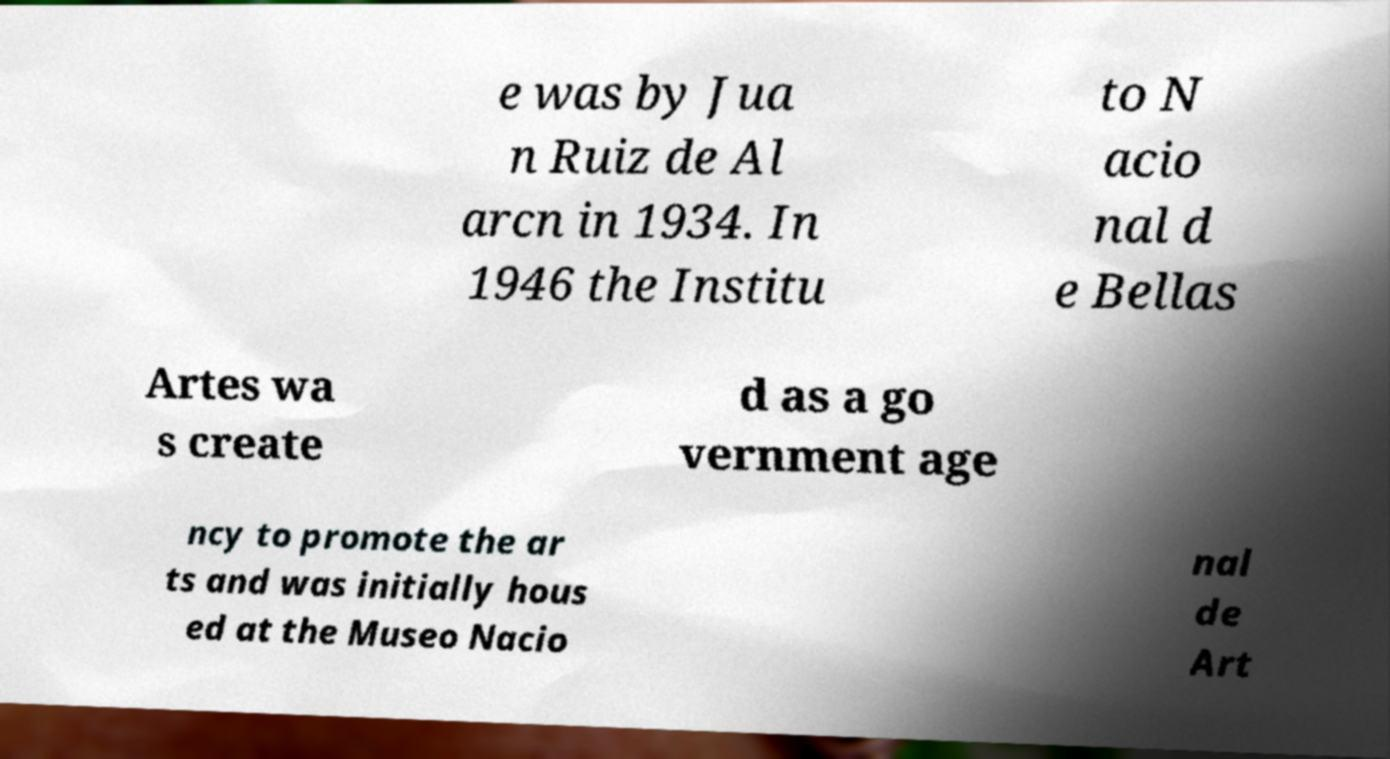Can you read and provide the text displayed in the image?This photo seems to have some interesting text. Can you extract and type it out for me? e was by Jua n Ruiz de Al arcn in 1934. In 1946 the Institu to N acio nal d e Bellas Artes wa s create d as a go vernment age ncy to promote the ar ts and was initially hous ed at the Museo Nacio nal de Art 